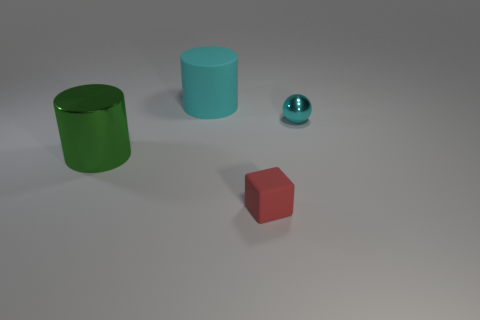Is the size of the cyan cylinder the same as the red rubber object?
Your answer should be compact. No. What is the size of the rubber thing that is in front of the shiny object that is right of the small red object?
Your answer should be compact. Small. There is a thing that is both behind the metal cylinder and in front of the large matte object; how big is it?
Make the answer very short. Small. How many red cubes are the same size as the ball?
Provide a succinct answer. 1. How many rubber objects are blue objects or red blocks?
Provide a succinct answer. 1. There is a cylinder that is the same color as the tiny sphere; what size is it?
Make the answer very short. Large. What material is the cyan object to the right of the large cylinder behind the green object?
Keep it short and to the point. Metal. What number of objects are cyan rubber cylinders or big rubber cylinders behind the big green cylinder?
Your answer should be compact. 1. The red cube that is made of the same material as the big cyan cylinder is what size?
Your answer should be very brief. Small. How many cyan objects are big cylinders or small rubber things?
Offer a terse response. 1. 